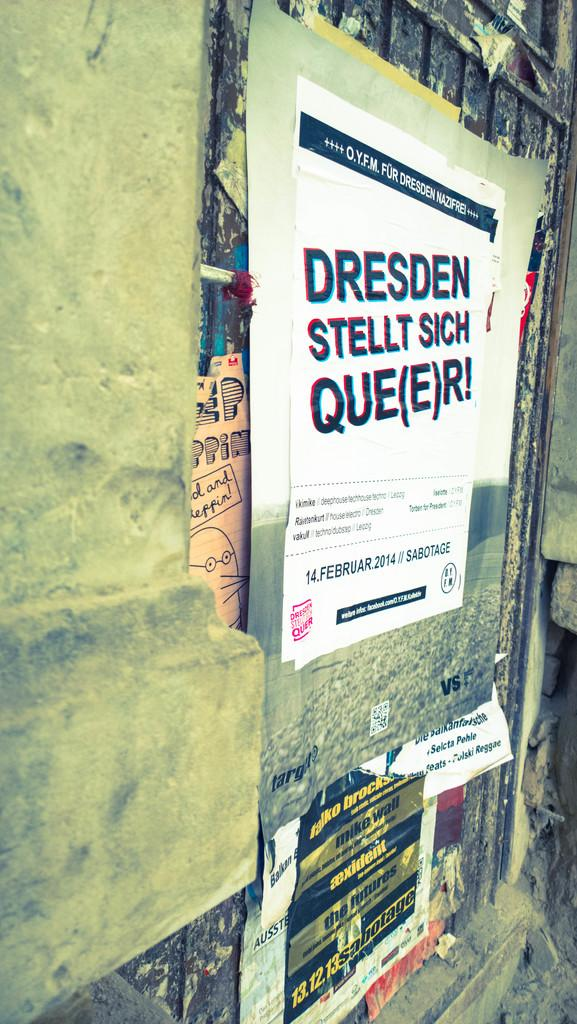<image>
Describe the image concisely. a poster on a wall that says 'dresden stellt sich que(e)r!' on it 